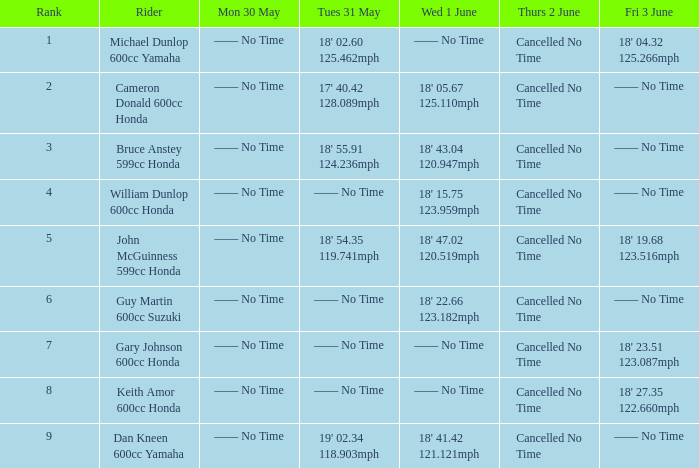66 12 —— No Time. 